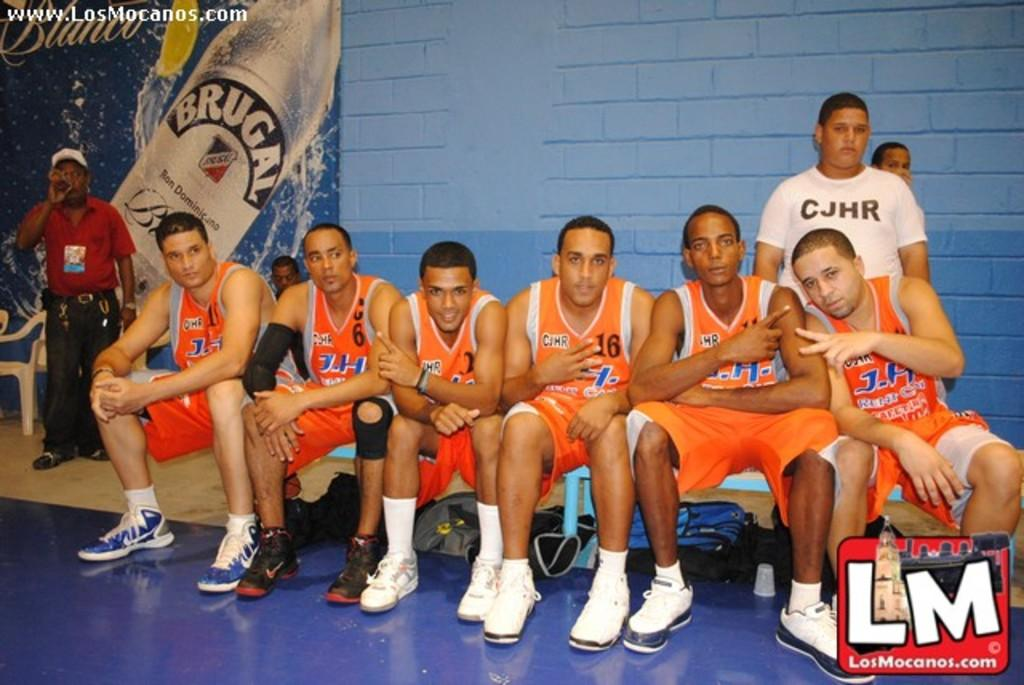<image>
Offer a succinct explanation of the picture presented. Basketball team photo with an ad for BRUGAL in the back. 